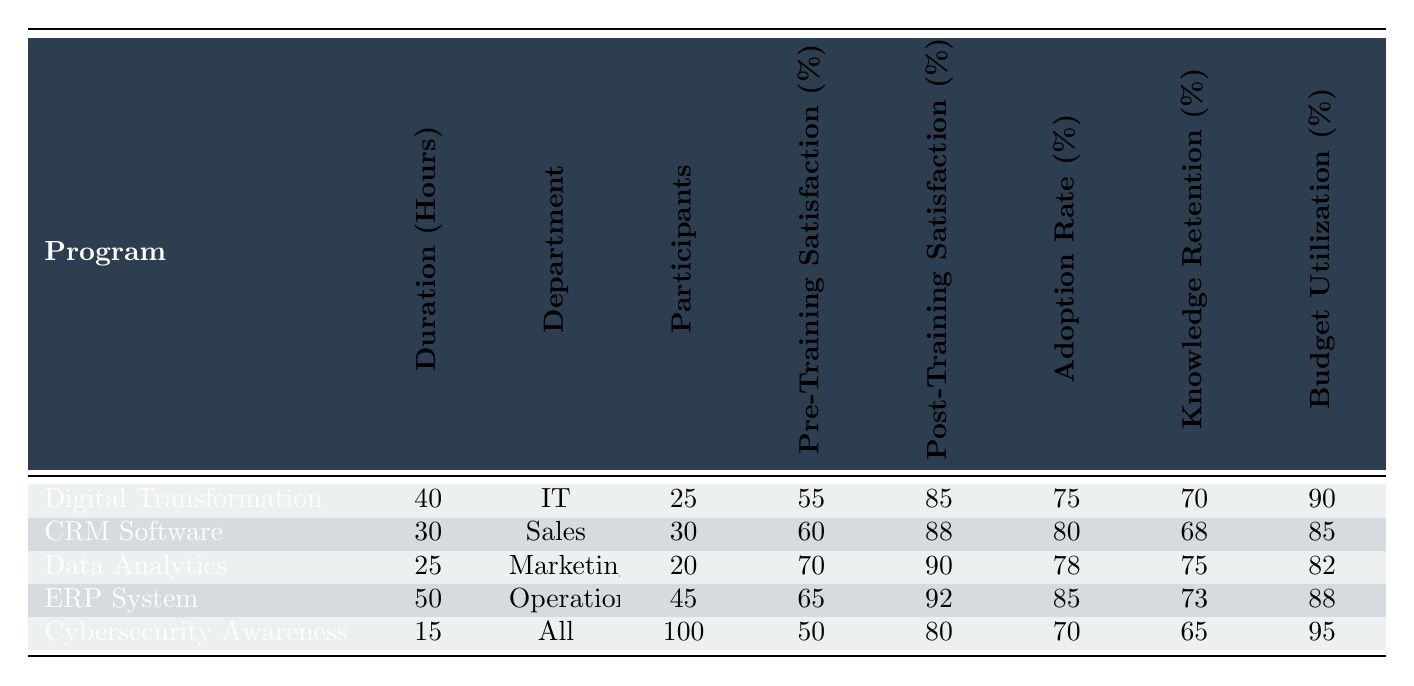What is the duration of the Cybersecurity Awareness Training program? The table shows that the duration for the Cybersecurity Awareness Training program is listed in the "Duration (Hours)" column. It is stated as 15 hours.
Answer: 15 Which program had the highest post-training satisfaction percentage? By looking at the "Post-Training Satisfaction (%)" column, the highest value is 92%, which corresponds to the ERP System Training program.
Answer: ERP System Training What is the average adoption rate of all training programs? To find the average, we add the adoption rates from all programs: (75 + 80 + 78 + 85 + 70) = 388. Then we divide by the number of programs (5), resulting in 388/5 = 77.6.
Answer: 77.6 Did the CRM Software Training program result in a higher adoption rate than the Cybersecurity Awareness Training? The adoption rate for CRM Software Training is 80%, while for Cybersecurity Awareness Training, it is 70%. Since 80% is greater than 70%, we can conclude it did have a higher rate.
Answer: Yes Which department had the most participants in training programs? By scanning the "Participants" column, Cybersecurity Awareness Training had 100 participants, more than any other program.
Answer: All 